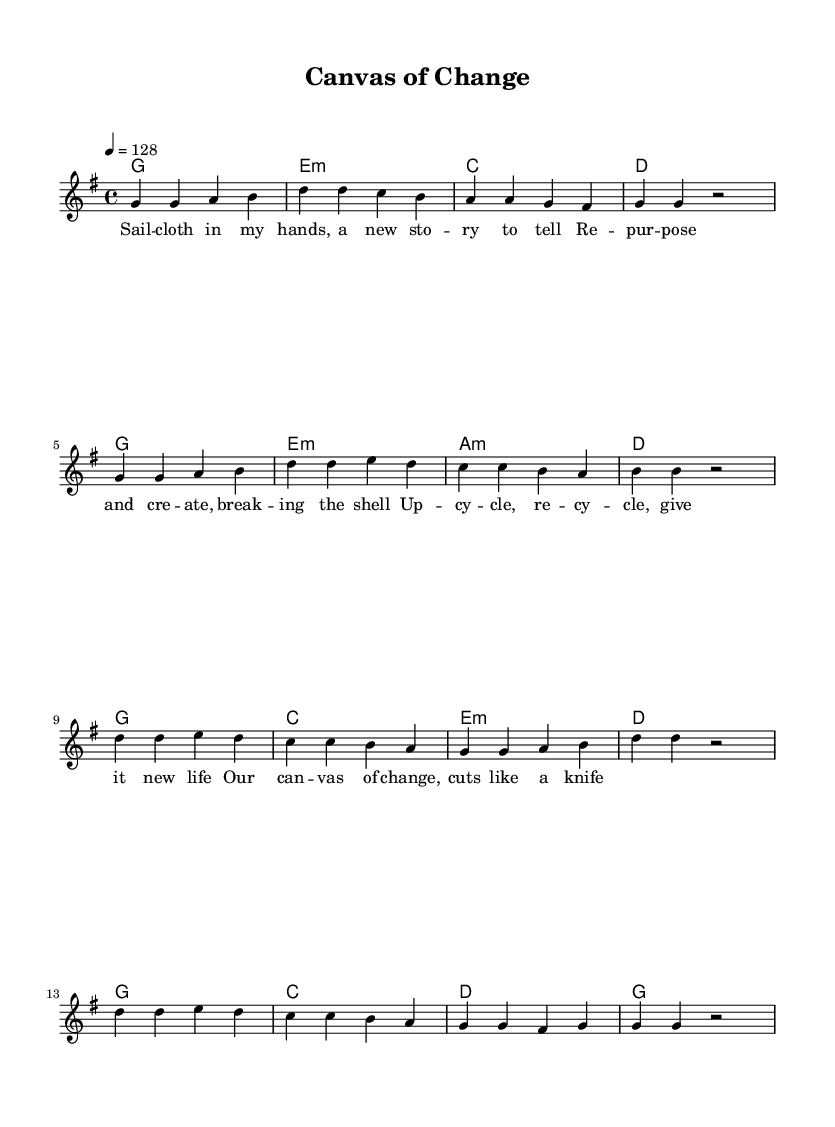What is the key signature of this music? The key signature is G major, which has one sharp (F#). This is determined by looking at the key signature at the beginning of the staff where the G major scale is indicated.
Answer: G major What is the time signature of this music? The time signature is 4/4, which is indicated at the beginning of the score. This means there are four beats in each measure and the quarter note receives one beat.
Answer: 4/4 What is the tempo of this piece? The tempo is 128 beats per minute, indicated at the start of the score with "4 = 128". This indicates how fast the music should be played.
Answer: 128 What is the first lyric of the verse? The first lyric of the verse is "Sail". This can be found in the lyrics section under the melody, where the words are aligned with the corresponding notes.
Answer: Sail How many measures are in the chorus? There are 8 measures in the chorus. To determine this, we count the measures in the section labeled as the chorus from the score.
Answer: 8 What artistic theme is reflected in the lyrics? The theme reflected in the lyrics is sustainability and repurposing. The lyrics discuss concepts such as re-purposing and creating art from new materials, indicating a focus on sustainable practices.
Answer: Sustainability What type of musical texture is primarily used in this piece? The primary texture used in this piece is homophonic. This is observed as the melody is supported by harmonies that follow the same rhythmic structure, creating a clear melody with chordal accompaniment.
Answer: Homophonic 